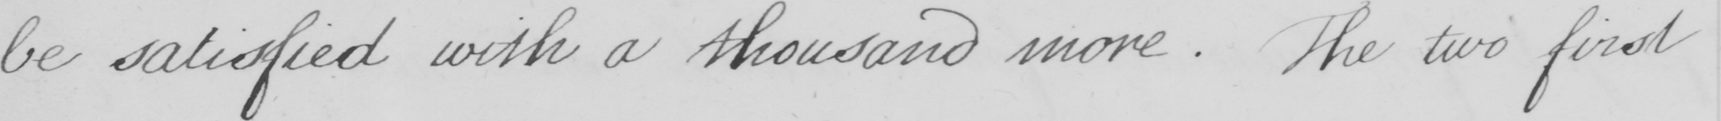Transcribe the text shown in this historical manuscript line. be satisfied with a thousand more . The two first 